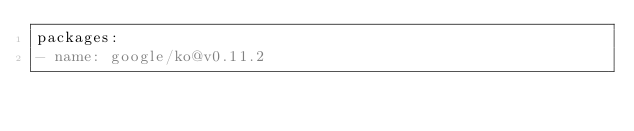<code> <loc_0><loc_0><loc_500><loc_500><_YAML_>packages:
- name: google/ko@v0.11.2
</code> 